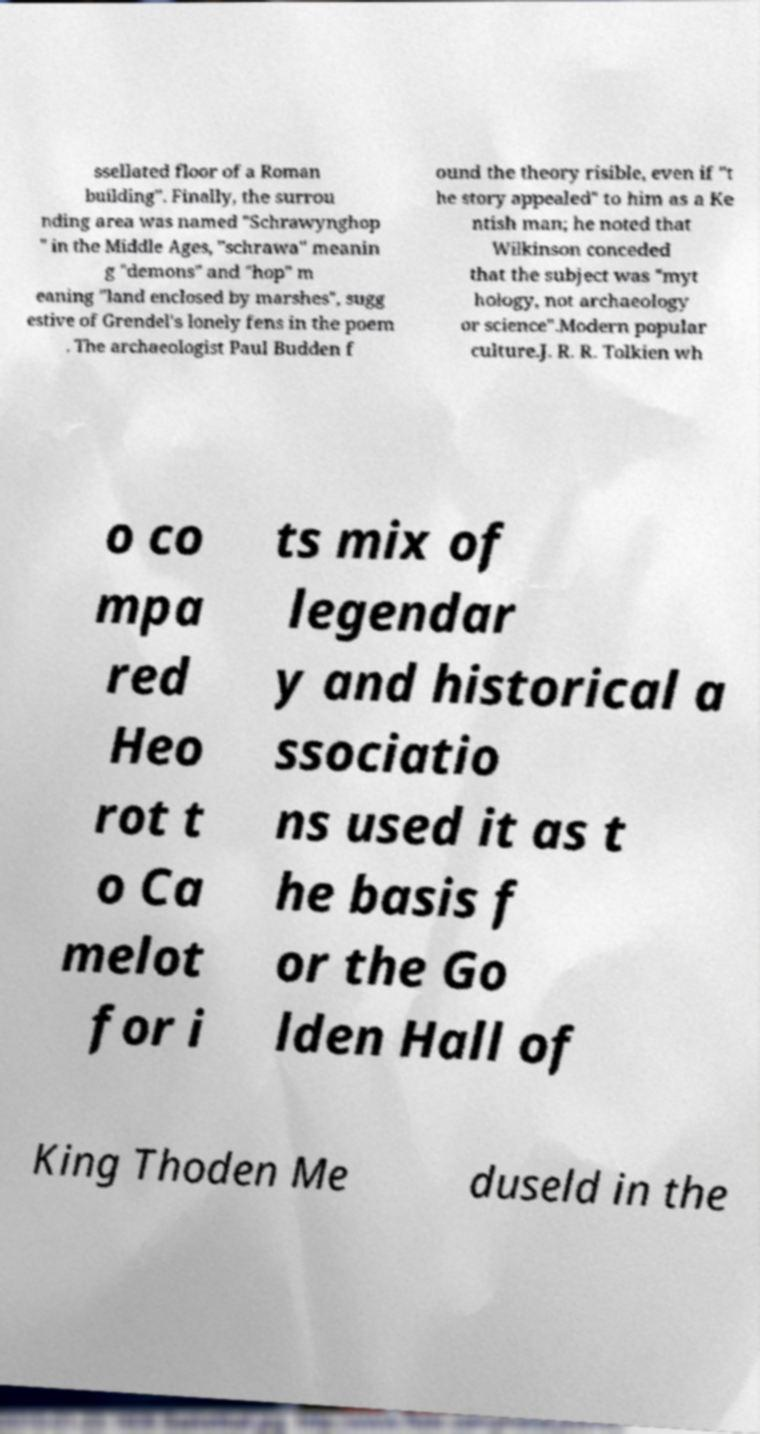Can you accurately transcribe the text from the provided image for me? ssellated floor of a Roman building". Finally, the surrou nding area was named "Schrawynghop " in the Middle Ages, "schrawa" meanin g "demons" and "hop" m eaning "land enclosed by marshes", sugg estive of Grendel's lonely fens in the poem . The archaeologist Paul Budden f ound the theory risible, even if "t he story appealed" to him as a Ke ntish man; he noted that Wilkinson conceded that the subject was "myt hology, not archaeology or science".Modern popular culture.J. R. R. Tolkien wh o co mpa red Heo rot t o Ca melot for i ts mix of legendar y and historical a ssociatio ns used it as t he basis f or the Go lden Hall of King Thoden Me duseld in the 